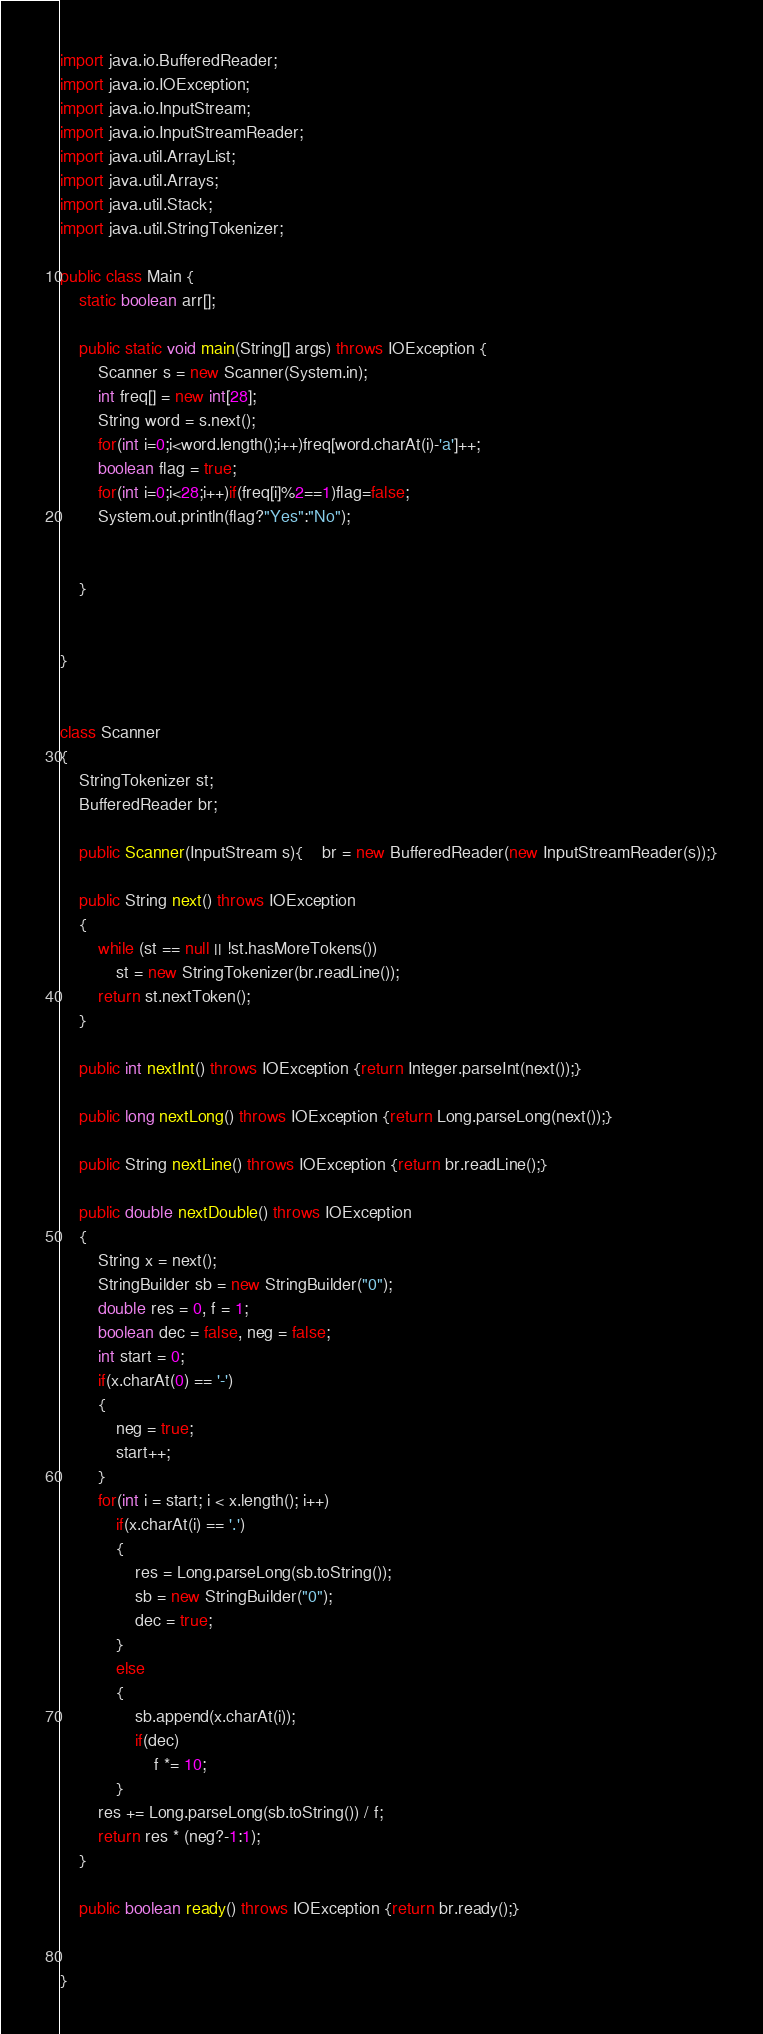<code> <loc_0><loc_0><loc_500><loc_500><_Java_>
import java.io.BufferedReader;
import java.io.IOException;
import java.io.InputStream;
import java.io.InputStreamReader;
import java.util.ArrayList;
import java.util.Arrays;
import java.util.Stack;
import java.util.StringTokenizer;

public class Main {
    static boolean arr[];

    public static void main(String[] args) throws IOException {
        Scanner s = new Scanner(System.in);
        int freq[] = new int[28];
        String word = s.next();
        for(int i=0;i<word.length();i++)freq[word.charAt(i)-'a']++;
        boolean flag = true;
        for(int i=0;i<28;i++)if(freq[i]%2==1)flag=false;
        System.out.println(flag?"Yes":"No");


    }


}


class Scanner
{
    StringTokenizer st;
    BufferedReader br;

    public Scanner(InputStream s){	br = new BufferedReader(new InputStreamReader(s));}

    public String next() throws IOException
    {
        while (st == null || !st.hasMoreTokens())
            st = new StringTokenizer(br.readLine());
        return st.nextToken();
    }

    public int nextInt() throws IOException {return Integer.parseInt(next());}

    public long nextLong() throws IOException {return Long.parseLong(next());}

    public String nextLine() throws IOException {return br.readLine();}

    public double nextDouble() throws IOException
    {
        String x = next();
        StringBuilder sb = new StringBuilder("0");
        double res = 0, f = 1;
        boolean dec = false, neg = false;
        int start = 0;
        if(x.charAt(0) == '-')
        {
            neg = true;
            start++;
        }
        for(int i = start; i < x.length(); i++)
            if(x.charAt(i) == '.')
            {
                res = Long.parseLong(sb.toString());
                sb = new StringBuilder("0");
                dec = true;
            }
            else
            {
                sb.append(x.charAt(i));
                if(dec)
                    f *= 10;
            }
        res += Long.parseLong(sb.toString()) / f;
        return res * (neg?-1:1);
    }

    public boolean ready() throws IOException {return br.ready();}


}</code> 